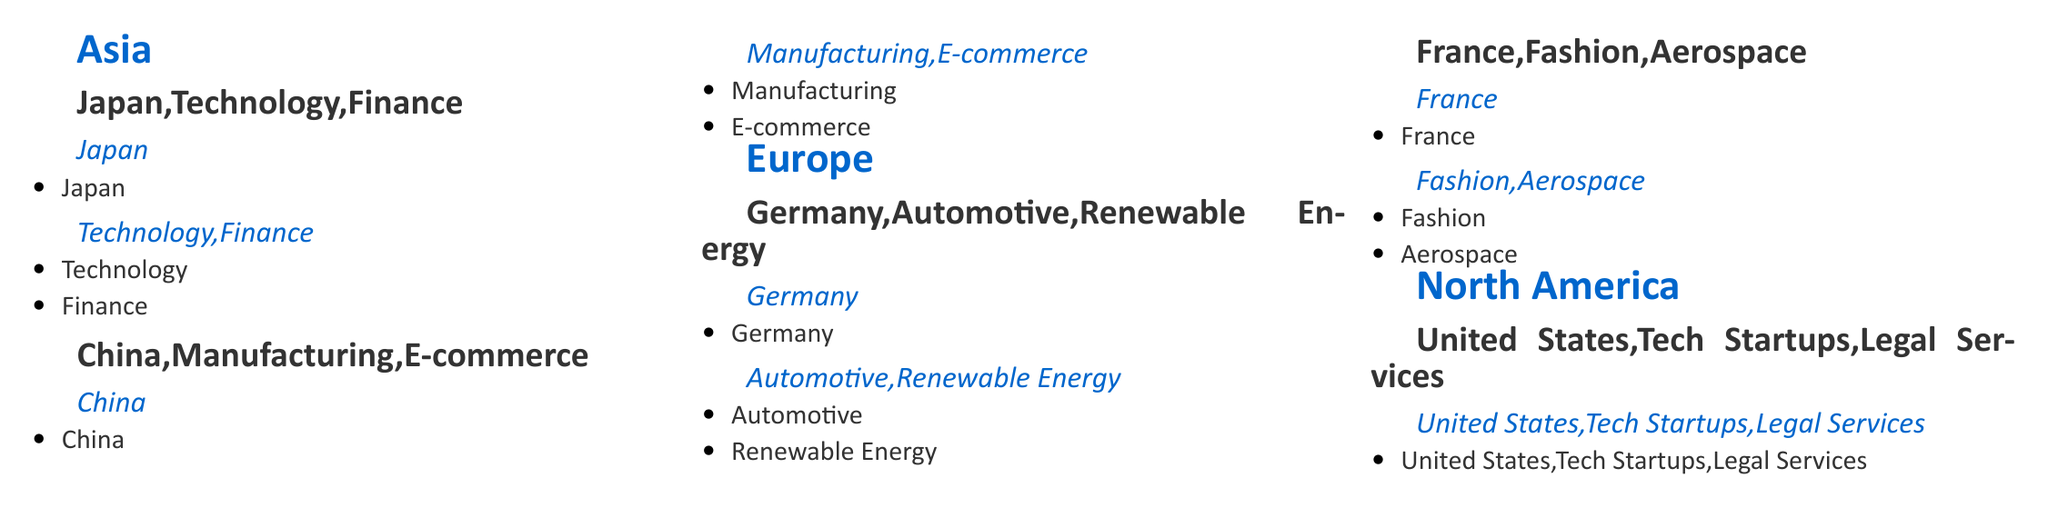What are the industries associated with Japan? The industries listed for Japan in the document are Technology and Finance.
Answer: Technology, Finance Which country has the industries of Automotive and Renewable Energy? Germany is the country associated with the industries of Automotive and Renewable Energy in the document.
Answer: Germany What are the sectors mentioned under United States? The sectors enumerated for the United States are Tech Startups and Legal Services.
Answer: Tech Startups, Legal Services How many countries are listed under Asia? There are two countries mentioned under Asia in the document: Japan and China.
Answer: 2 Which country in Europe is listed with the Fashion industry? France is identified as the country associated with the Fashion industry in the document.
Answer: France What is the title of the document? The title of the document is "Global Business Etiquette Catalog."
Answer: Global Business Etiquette Catalog What is the color used for headings in the document? The color assigned for headings is dark blue, specifically given the RGB values defined in the document.
Answer: Dark blue Which Asian country is associated with E-commerce? China is the Asian country related to E-commerce according to the document.
Answer: China What industry sectors are listed for Germany? The industry sectors listed for Germany in the document are Automotive and Renewable Energy.
Answer: Automotive, Renewable Energy 